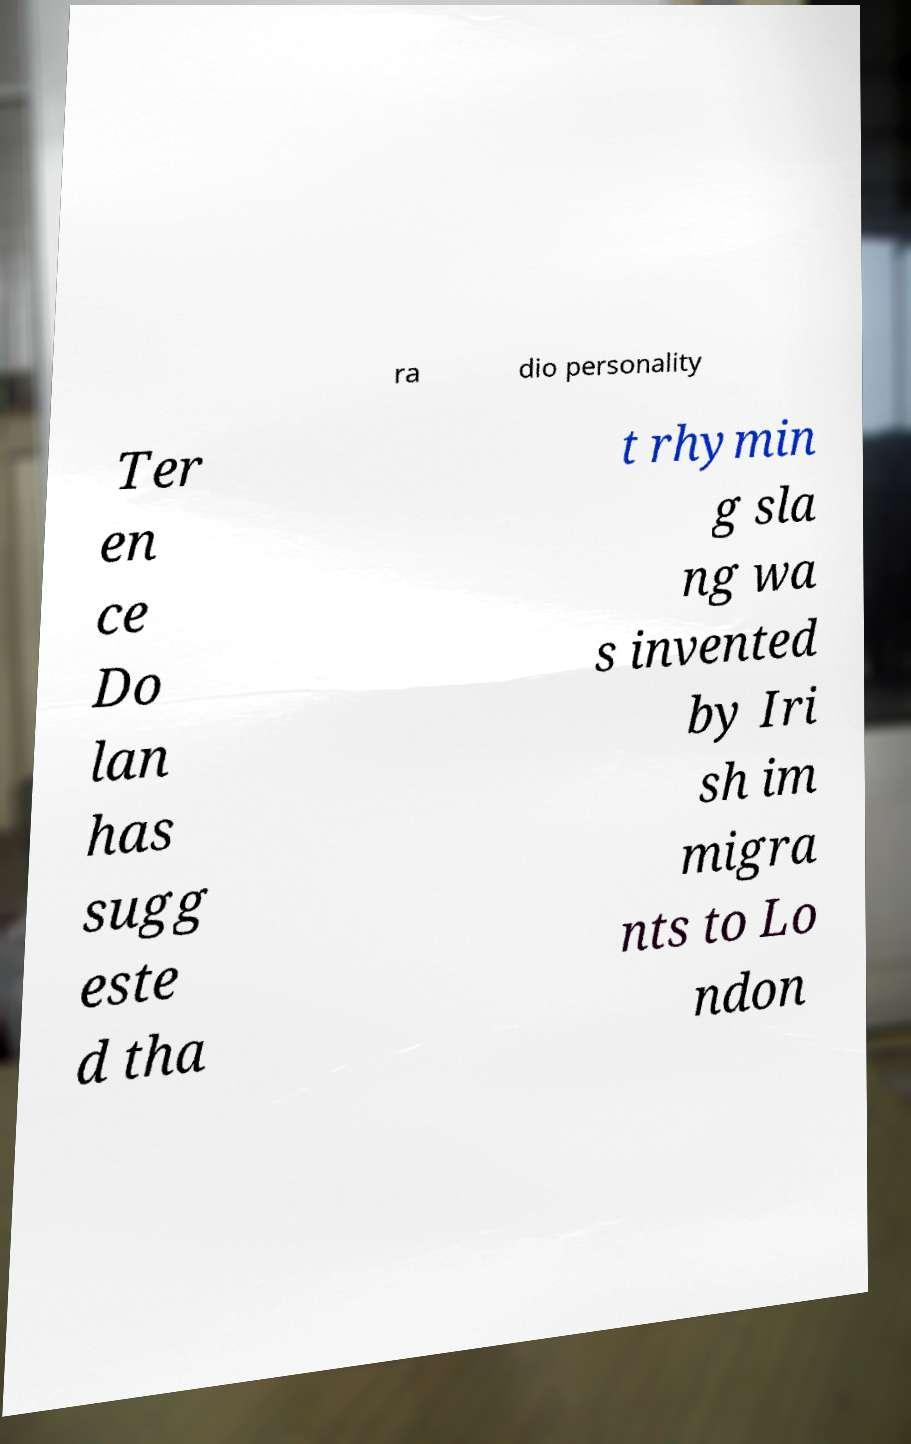Could you extract and type out the text from this image? ra dio personality Ter en ce Do lan has sugg este d tha t rhymin g sla ng wa s invented by Iri sh im migra nts to Lo ndon 